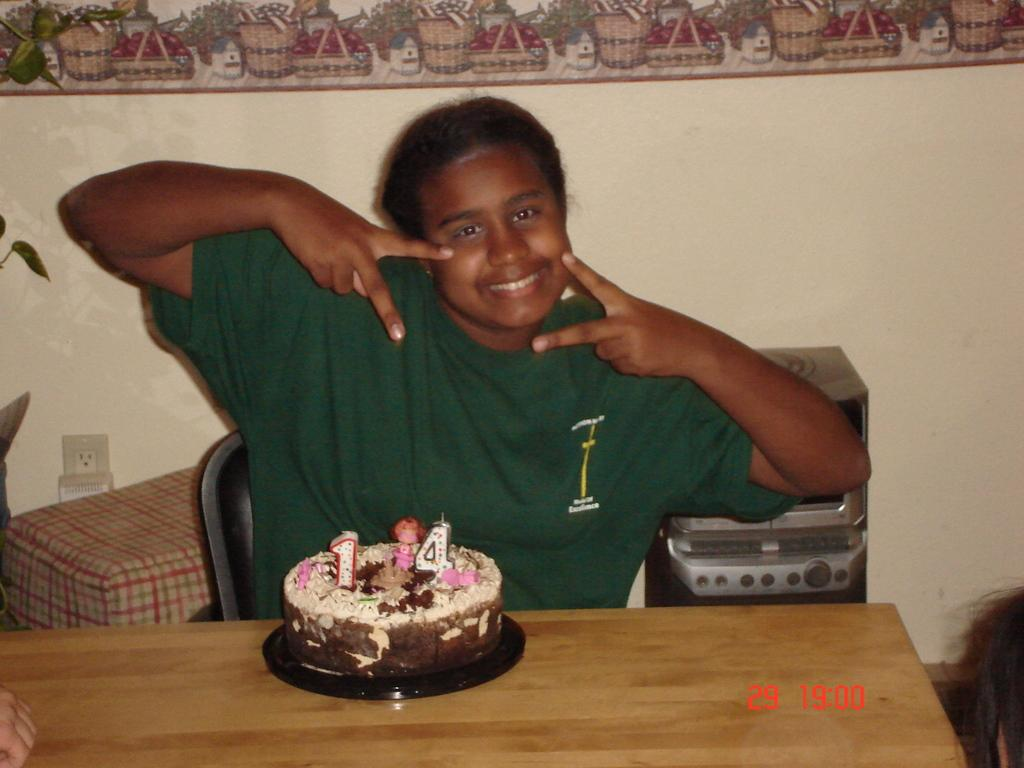What is the main subject of the image? There is a person in the image. What is the person wearing? The person is wearing a green shirt. What is the person doing in the image? The person is sitting on a chair. Where is the chair located in relation to the table? The chair is in front of a table. What is on the table? There is a cake on the table. What is located behind the person? There is a desk and a speaker behind the person. What type of lace can be seen on the person's shoes in the image? There is no mention of shoes or lace in the provided facts, so we cannot determine if there is any lace present in the image. --- Facts: 1. There is a car in the image. 2. The car is red. 3. The car has four wheels. 4. There is a road in the image. 5. The road is paved. 6. There are trees on the side of the road. Absurd Topics: parrot, sand, dance Conversation: What is the main subject of the image? There is a car in the image. What color is the car? The car is red. How many wheels does the car have? The car has four wheels. What is the surface of the road in the image? The road is paved. What type of vegetation is present on the side of the road? There are trees on the side of the road. Reasoning: Let's think step by step in order to produce the conversation. We start by identifying the main subject of the image, which is the car. Then, we describe the car's color and number of wheels. Next, we focus on the road and its surface, as well as the vegetation on the side of the road. Each question is designed to elicit a specific detail about the image that is known from the provided facts. Absurd Question/Answer: Can you tell me how many parrots are sitting on the car's roof in the image? There is no mention of parrots in the provided facts, so we cannot determine if there are any parrots present in the image. 